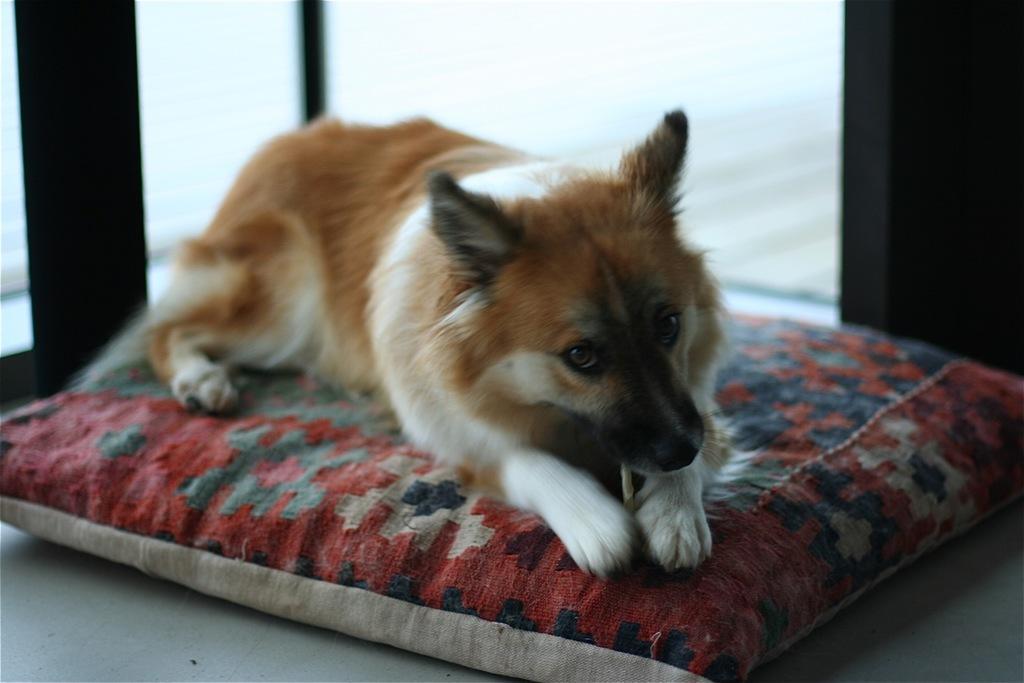Could you give a brief overview of what you see in this image? This is a dog sitting on the cushion. In the background, I think this is a door. This cushion is placed on the floor. 